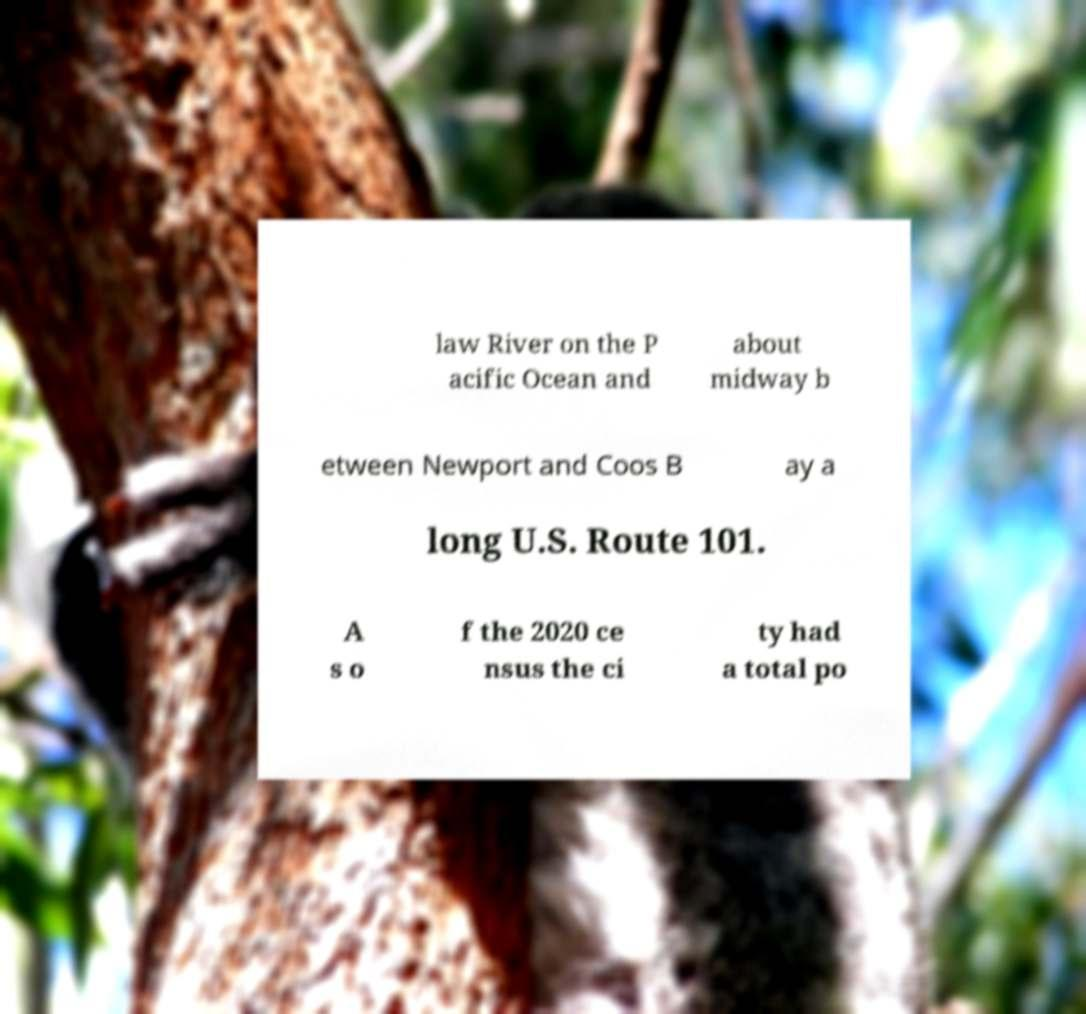Can you read and provide the text displayed in the image?This photo seems to have some interesting text. Can you extract and type it out for me? law River on the P acific Ocean and about midway b etween Newport and Coos B ay a long U.S. Route 101. A s o f the 2020 ce nsus the ci ty had a total po 